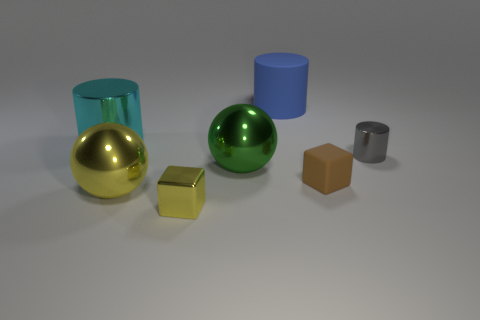What is the color of the cylinder that is the same size as the blue rubber object?
Offer a very short reply. Cyan. How many other objects are the same color as the small shiny cube?
Offer a terse response. 1. Is the number of tiny things behind the small yellow shiny block greater than the number of large blue metal blocks?
Offer a very short reply. Yes. Is the big yellow thing made of the same material as the small brown thing?
Your answer should be compact. No. What number of objects are either shiny cylinders that are right of the large cyan metallic thing or rubber things?
Provide a succinct answer. 3. What number of other objects are there of the same size as the blue thing?
Give a very brief answer. 3. Are there an equal number of small shiny cylinders that are on the right side of the tiny gray cylinder and large yellow things that are on the right side of the large cyan cylinder?
Provide a succinct answer. No. There is a small metallic object that is the same shape as the large cyan metal thing; what is its color?
Keep it short and to the point. Gray. There is a big metal sphere that is to the left of the small yellow shiny cube; is it the same color as the metal block?
Offer a terse response. Yes. What size is the other object that is the same shape as the small brown matte thing?
Offer a terse response. Small. 